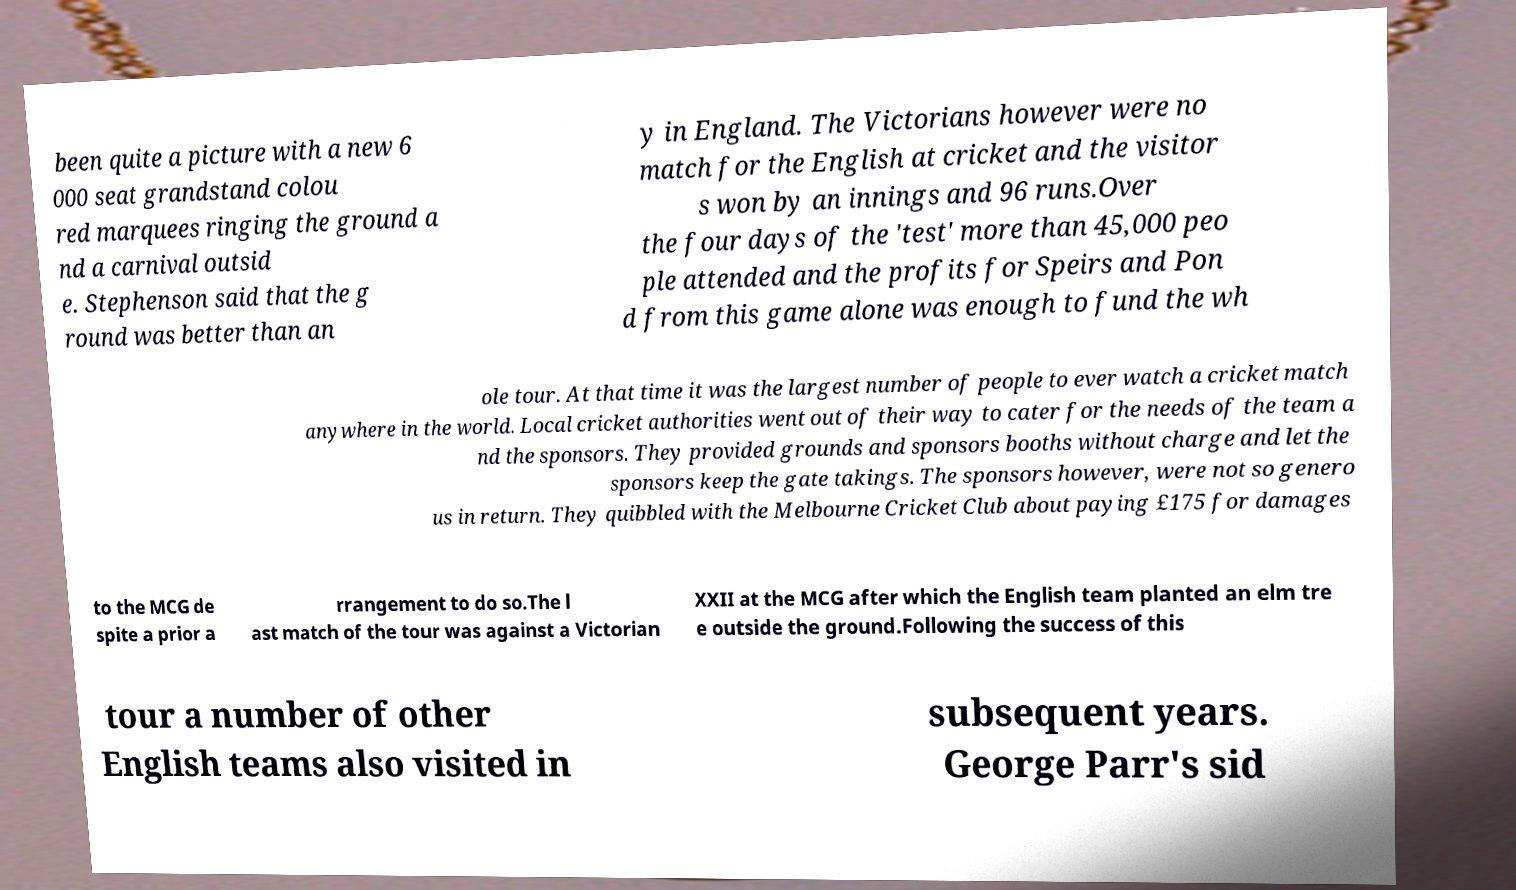What messages or text are displayed in this image? I need them in a readable, typed format. been quite a picture with a new 6 000 seat grandstand colou red marquees ringing the ground a nd a carnival outsid e. Stephenson said that the g round was better than an y in England. The Victorians however were no match for the English at cricket and the visitor s won by an innings and 96 runs.Over the four days of the 'test' more than 45,000 peo ple attended and the profits for Speirs and Pon d from this game alone was enough to fund the wh ole tour. At that time it was the largest number of people to ever watch a cricket match anywhere in the world. Local cricket authorities went out of their way to cater for the needs of the team a nd the sponsors. They provided grounds and sponsors booths without charge and let the sponsors keep the gate takings. The sponsors however, were not so genero us in return. They quibbled with the Melbourne Cricket Club about paying £175 for damages to the MCG de spite a prior a rrangement to do so.The l ast match of the tour was against a Victorian XXII at the MCG after which the English team planted an elm tre e outside the ground.Following the success of this tour a number of other English teams also visited in subsequent years. George Parr's sid 